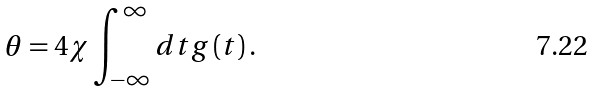Convert formula to latex. <formula><loc_0><loc_0><loc_500><loc_500>\theta = 4 \chi \int _ { - \infty } ^ { \infty } d t g \left ( t \right ) .</formula> 